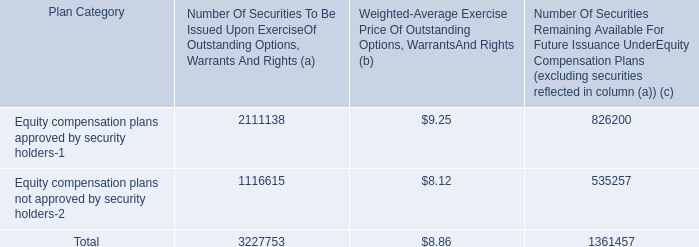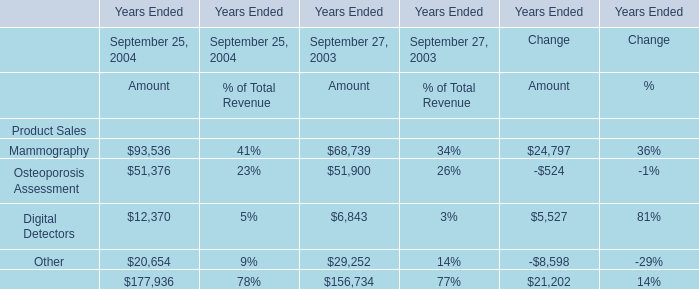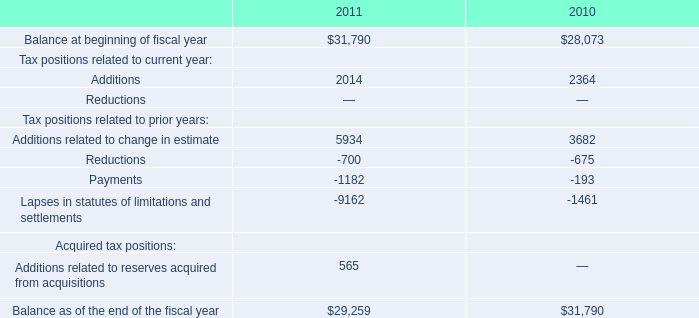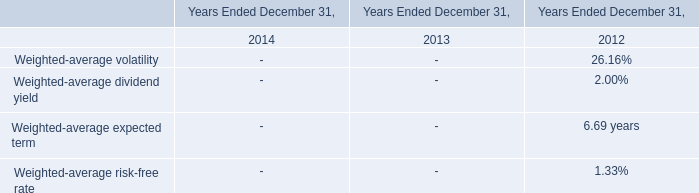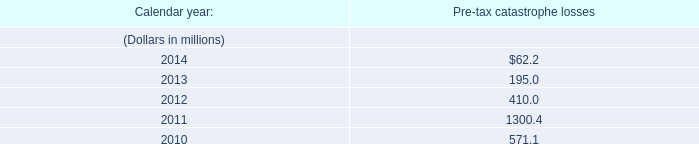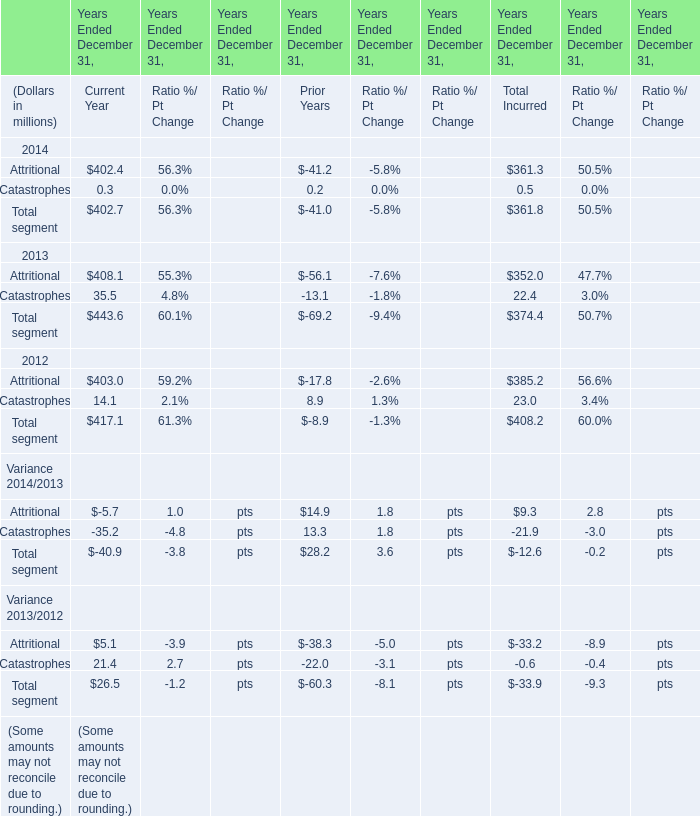What's the average of Other of Years Ended September 25, 2004 Amount, and Balance at beginning of fiscal year of 2010 ? 
Computations: ((20654.0 + 28073.0) / 2)
Answer: 24363.5. 